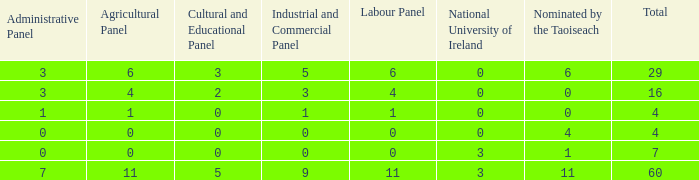What is the average nominated of the composition nominated by Taioseach with an Industrial and Commercial panel less than 9, an administrative panel greater than 0, a cultural and educational panel greater than 2, and a total less than 29? None. 